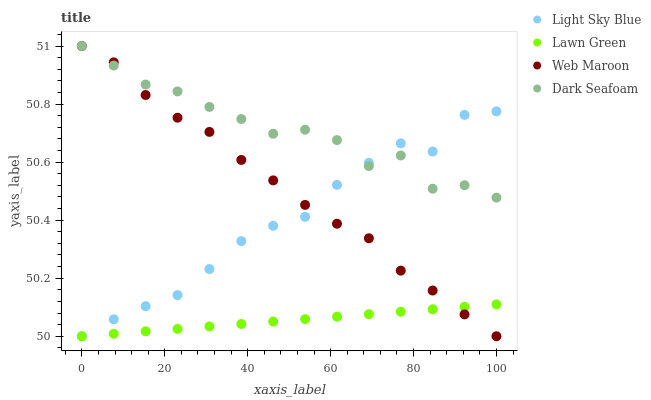Does Lawn Green have the minimum area under the curve?
Answer yes or no. Yes. Does Dark Seafoam have the maximum area under the curve?
Answer yes or no. Yes. Does Light Sky Blue have the minimum area under the curve?
Answer yes or no. No. Does Light Sky Blue have the maximum area under the curve?
Answer yes or no. No. Is Lawn Green the smoothest?
Answer yes or no. Yes. Is Dark Seafoam the roughest?
Answer yes or no. Yes. Is Light Sky Blue the smoothest?
Answer yes or no. No. Is Light Sky Blue the roughest?
Answer yes or no. No. Does Lawn Green have the lowest value?
Answer yes or no. Yes. Does Dark Seafoam have the lowest value?
Answer yes or no. No. Does Web Maroon have the highest value?
Answer yes or no. Yes. Does Light Sky Blue have the highest value?
Answer yes or no. No. Is Lawn Green less than Dark Seafoam?
Answer yes or no. Yes. Is Dark Seafoam greater than Lawn Green?
Answer yes or no. Yes. Does Lawn Green intersect Web Maroon?
Answer yes or no. Yes. Is Lawn Green less than Web Maroon?
Answer yes or no. No. Is Lawn Green greater than Web Maroon?
Answer yes or no. No. Does Lawn Green intersect Dark Seafoam?
Answer yes or no. No. 